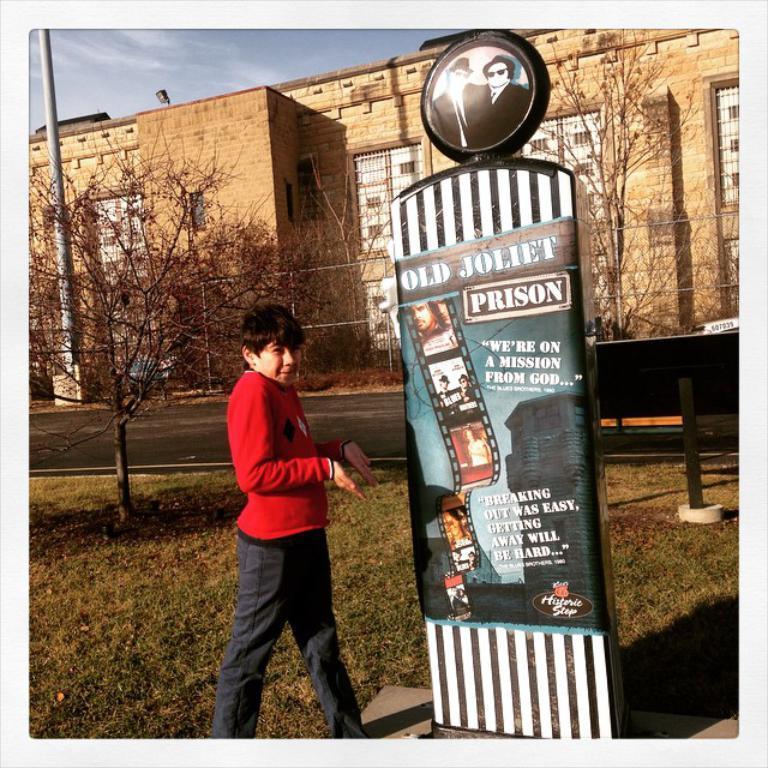In one or two sentences, can you explain what this image depicts? In this image I can see the person with the red and black color dress. To the side of the person I can see the board. In the background I can see many trees, pole and the building. I can also see the sky in the back. 